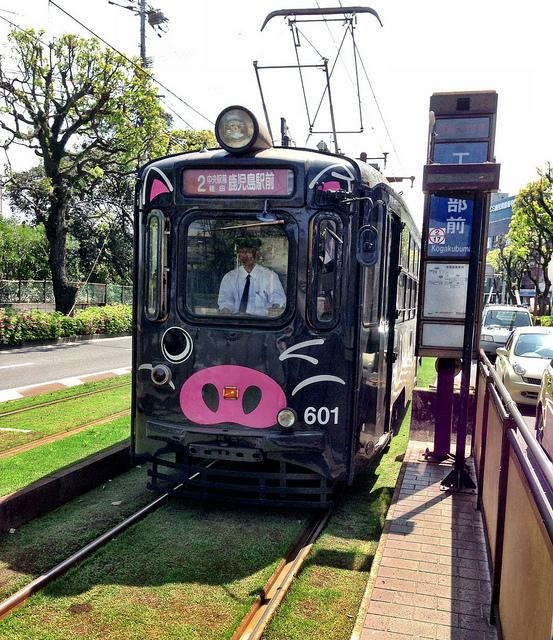How is the trolley powered? electricity 